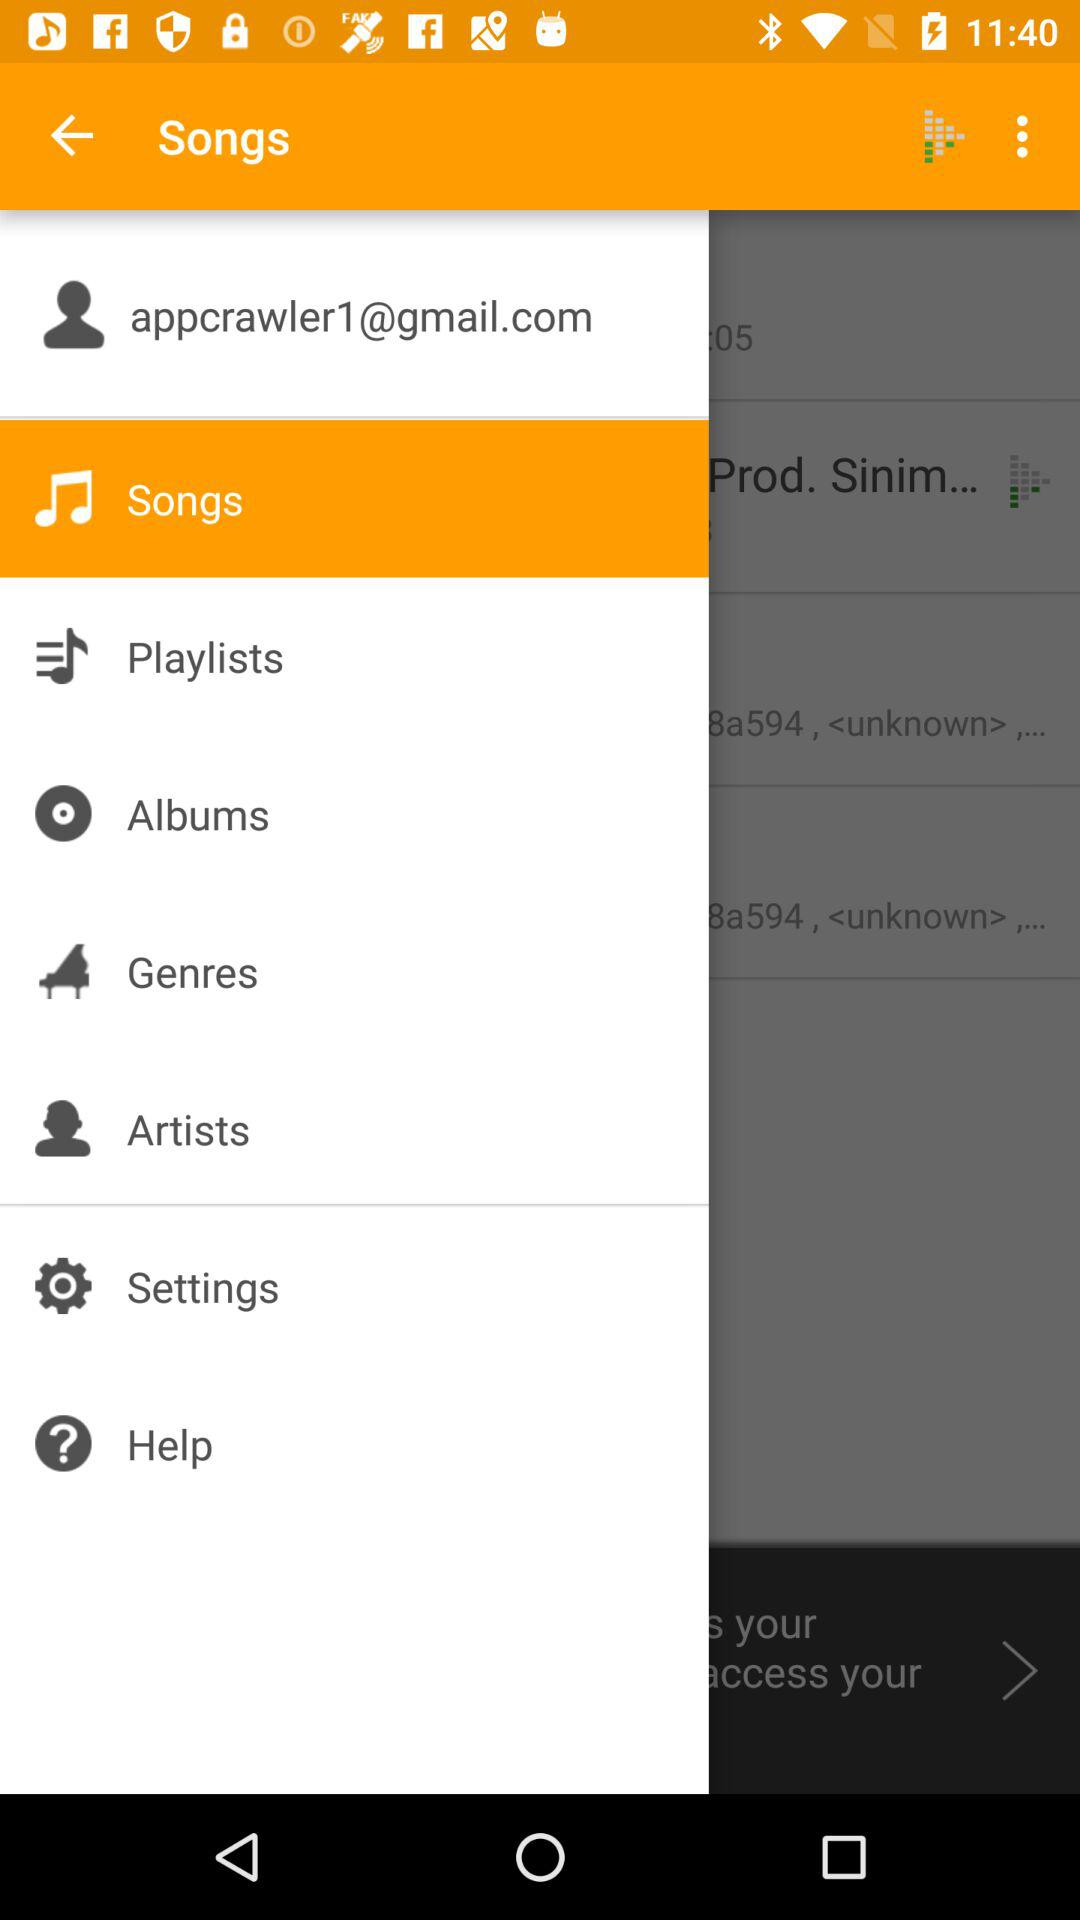Is the user male or female?
When the provided information is insufficient, respond with <no answer>. <no answer> 